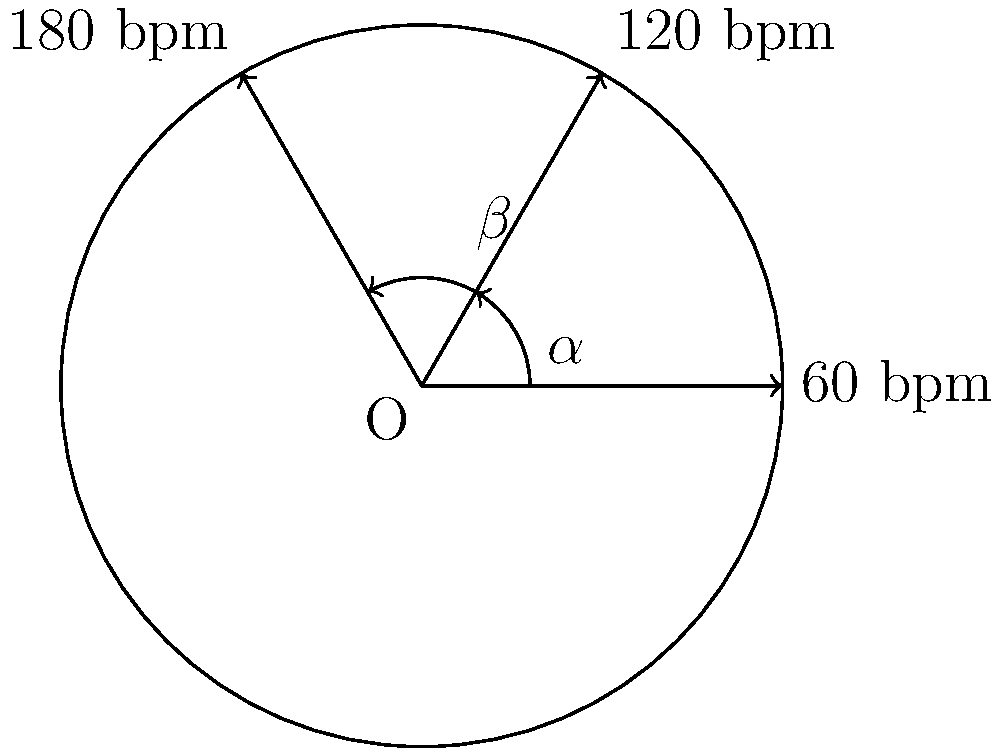A metronome's arm oscillates at different tempos, forming angles between its positions. If the arm moves from 60 beats per minute (bpm) to 120 bpm, creating angle $\alpha$, and then from 120 bpm to 180 bpm, forming angle $\beta$, what is the ratio of $\alpha$ to $\beta$? Let's approach this step-by-step:

1) In a circle, angles are proportional to the arc lengths they subtend.

2) The tempo markings on a metronome are typically evenly spaced around the circle.

3) The angle between each tempo marking is proportional to the difference in tempos:
   - From 60 bpm to 120 bpm: $120 - 60 = 60$ units
   - From 120 bpm to 180 bpm: $180 - 120 = 60$ units

4) Since both intervals represent 60 units of tempo difference, they correspond to equal angles.

5) Therefore, angle $\alpha$ (from 60 bpm to 120 bpm) is equal to angle $\beta$ (from 120 bpm to 180 bpm).

6) The ratio of equal quantities is always 1:1.

Thus, the ratio of $\alpha$ to $\beta$ is 1:1.
Answer: 1:1 